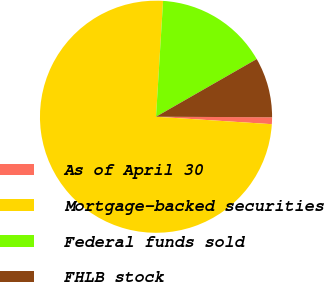Convert chart. <chart><loc_0><loc_0><loc_500><loc_500><pie_chart><fcel>As of April 30<fcel>Mortgage-backed securities<fcel>Federal funds sold<fcel>FHLB stock<nl><fcel>0.95%<fcel>74.94%<fcel>15.75%<fcel>8.35%<nl></chart> 